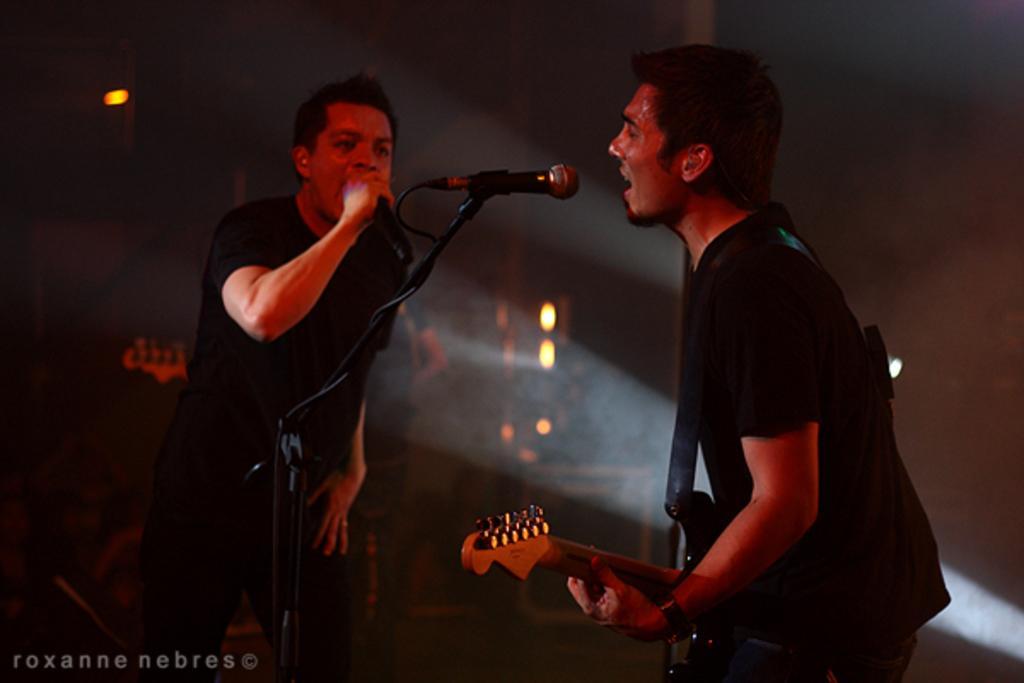Please provide a concise description of this image. These two persons are standing. This man is playing guitar and singing in-front of mic. This man is also singing in-front of mic. On top there are lights. 